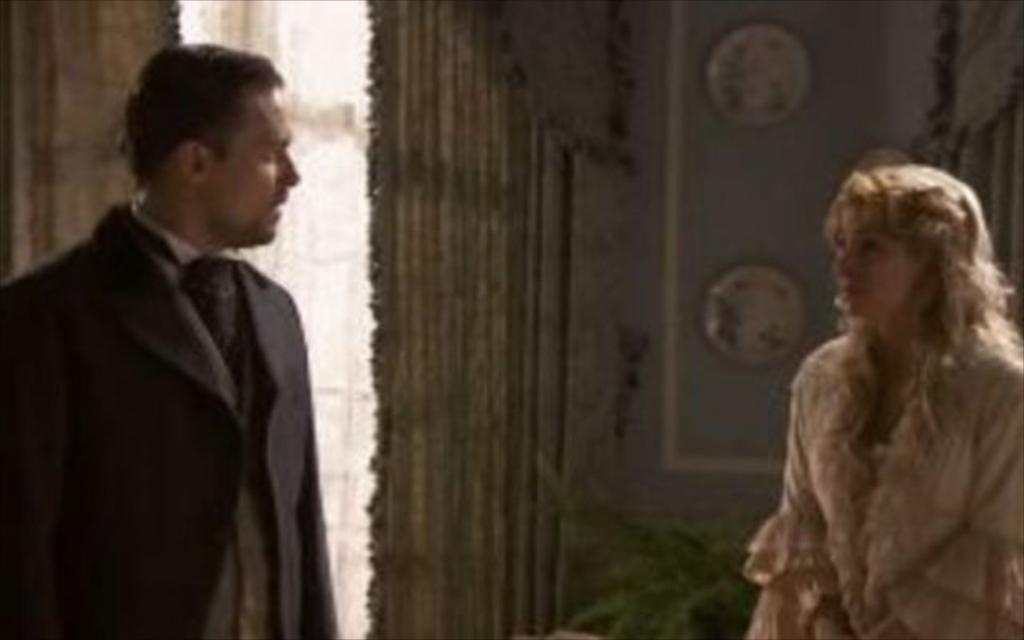How many people are present in the image? There are two people, a man and a woman, present in the image. What can be seen in the background of the image? There is a wall and a plant in the background of the image. What type of bait is the man using to catch the thunder in the image? There is no bait or thunder present in the image; it features a man and a woman with a wall and a plant in the background. 